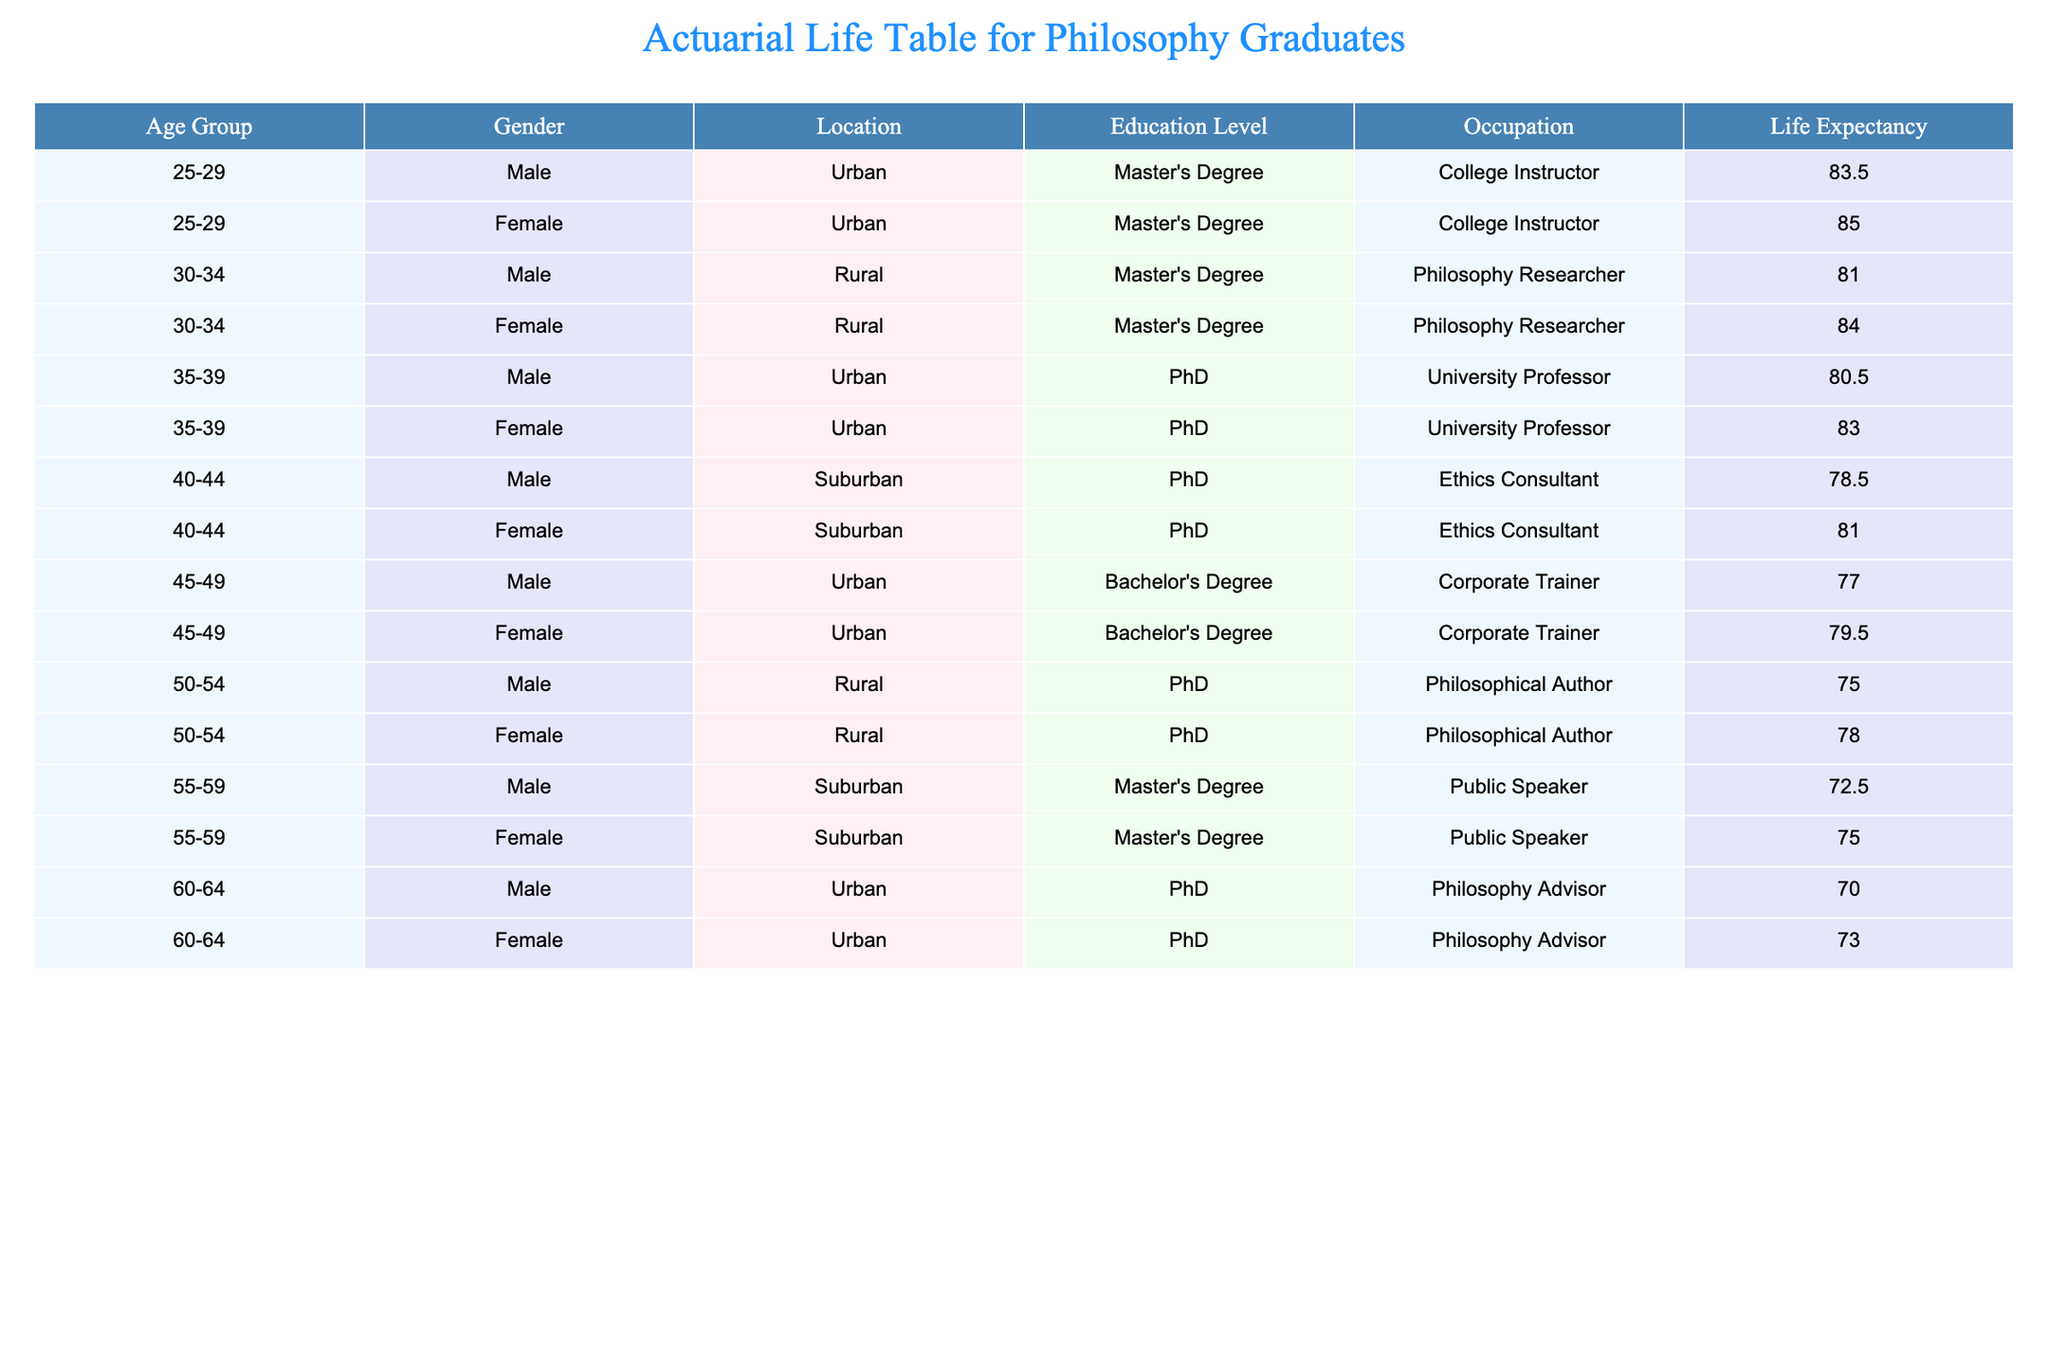What is the life expectancy of urban college instructors? From the table, we can see the life expectancy for both male and female urban college instructors. For males aged 25-29, it is 83.5 years, and for females, it's 85.0 years. Therefore, the average life expectancy for urban college instructors can be calculated as (83.5 + 85.0) / 2 = 84.25 years.
Answer: 84.25 years Is a suburban female ethic consultant expected to live longer than an urban male corporate trainer? The life expectancy for the suburban female ethic consultant is 81.0 years, and for the urban male corporate trainer, it is 77.0 years. Since 81.0 is greater than 77.0, the answer is yes.
Answer: Yes What is the average life expectancy of males aged 50-54? From the table, the life expectancies for males aged 50-54 are 75.0 years (rural, philosophical author). There is only one male data point for this age group, so the average is simply 75.0 years.
Answer: 75.0 years Do females with a PhD in urban settings generally have a higher life expectancy than males in the same demographic? For females with a PhD, the life expectancy is 83.0 years, while for males, it is 80.5 years. Since 83.0 is greater than 80.5, the answer is yes.
Answer: Yes What is the difference in life expectancy between urban males with a bachelor’s degree aged 45-49 and those with a PhD aged 35-39? The life expectancy for urban males aged 45-49 with a bachelor’s degree is 77.0 years, and for those aged 35-39 with a PhD, it is 80.5 years. The difference is 80.5 - 77.0 = 3.5 years.
Answer: 3.5 years 